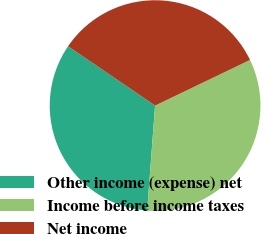<chart> <loc_0><loc_0><loc_500><loc_500><pie_chart><fcel>Other income (expense) net<fcel>Income before income taxes<fcel>Net income<nl><fcel>33.33%<fcel>33.33%<fcel>33.34%<nl></chart> 